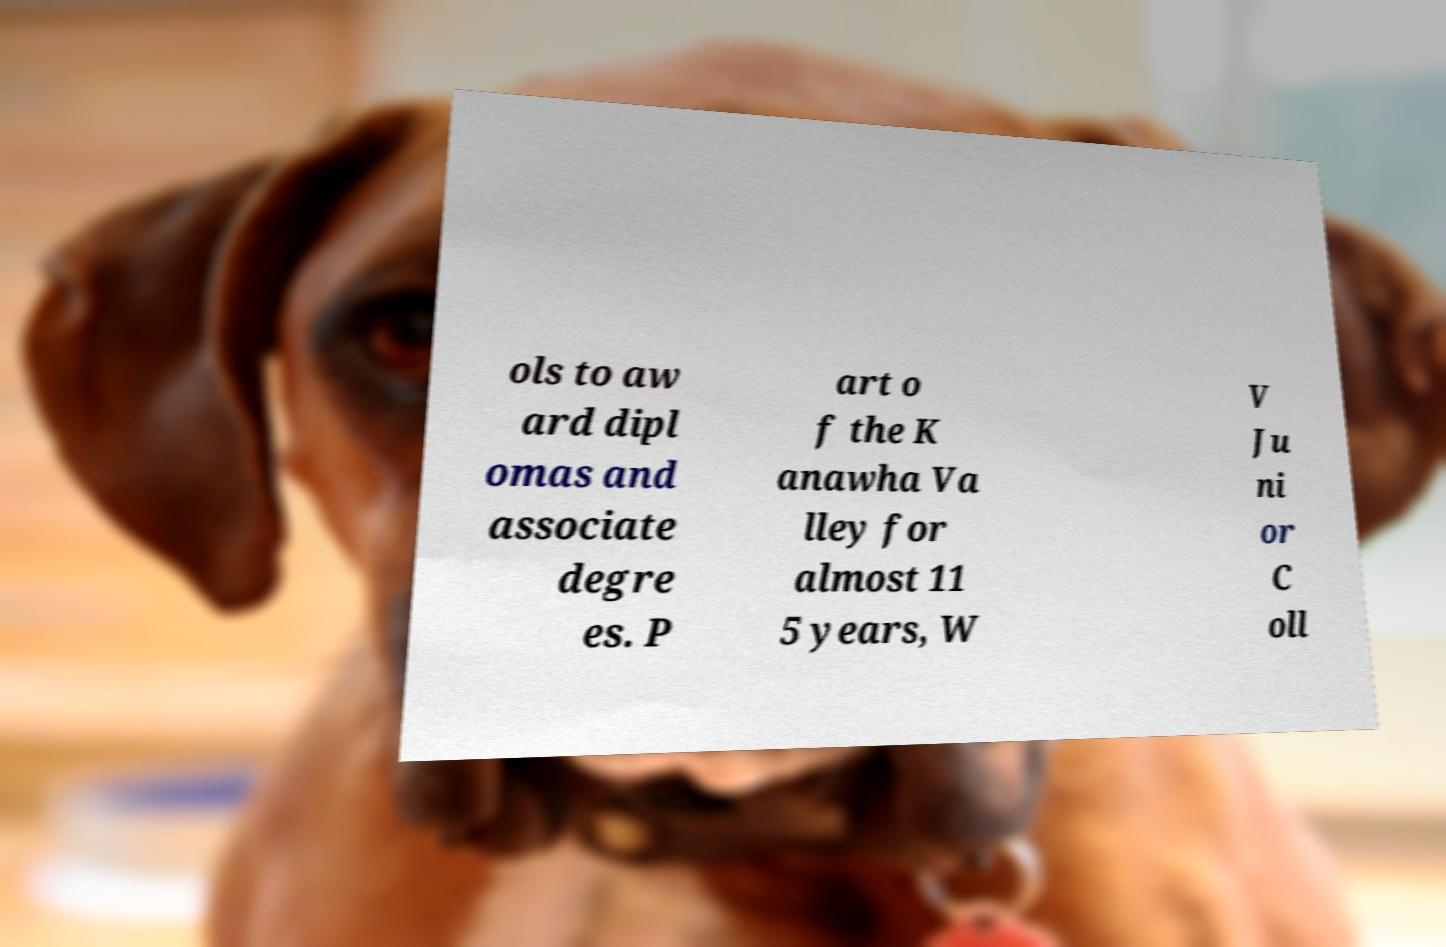What messages or text are displayed in this image? I need them in a readable, typed format. ols to aw ard dipl omas and associate degre es. P art o f the K anawha Va lley for almost 11 5 years, W V Ju ni or C oll 